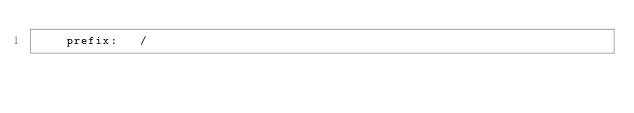<code> <loc_0><loc_0><loc_500><loc_500><_YAML_>    prefix:   /
</code> 